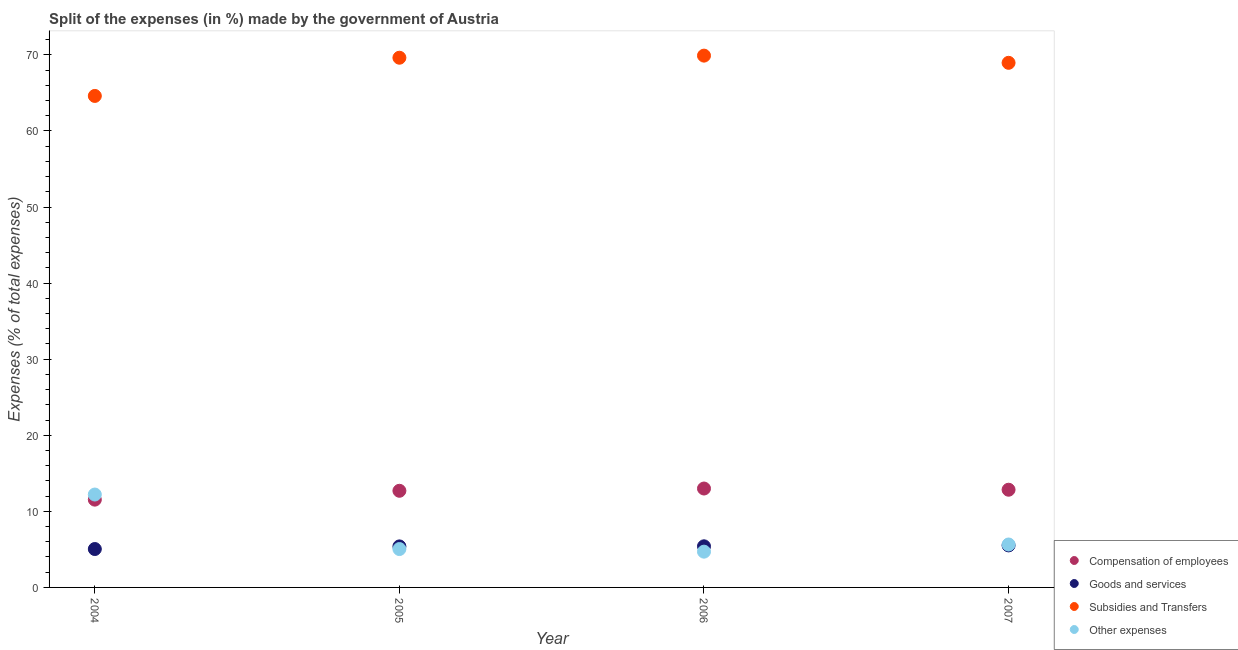How many different coloured dotlines are there?
Your response must be concise. 4. Is the number of dotlines equal to the number of legend labels?
Give a very brief answer. Yes. What is the percentage of amount spent on goods and services in 2004?
Your answer should be very brief. 5.05. Across all years, what is the maximum percentage of amount spent on subsidies?
Offer a terse response. 69.9. Across all years, what is the minimum percentage of amount spent on compensation of employees?
Keep it short and to the point. 11.54. In which year was the percentage of amount spent on other expenses maximum?
Ensure brevity in your answer.  2004. What is the total percentage of amount spent on subsidies in the graph?
Your answer should be compact. 273.09. What is the difference between the percentage of amount spent on compensation of employees in 2005 and that in 2007?
Keep it short and to the point. -0.14. What is the difference between the percentage of amount spent on goods and services in 2006 and the percentage of amount spent on other expenses in 2005?
Offer a very short reply. 0.36. What is the average percentage of amount spent on compensation of employees per year?
Your answer should be compact. 12.52. In the year 2004, what is the difference between the percentage of amount spent on compensation of employees and percentage of amount spent on subsidies?
Keep it short and to the point. -53.07. In how many years, is the percentage of amount spent on subsidies greater than 26 %?
Keep it short and to the point. 4. What is the ratio of the percentage of amount spent on compensation of employees in 2004 to that in 2005?
Ensure brevity in your answer.  0.91. Is the difference between the percentage of amount spent on compensation of employees in 2005 and 2006 greater than the difference between the percentage of amount spent on subsidies in 2005 and 2006?
Offer a very short reply. No. What is the difference between the highest and the second highest percentage of amount spent on compensation of employees?
Ensure brevity in your answer.  0.16. What is the difference between the highest and the lowest percentage of amount spent on goods and services?
Provide a succinct answer. 0.48. In how many years, is the percentage of amount spent on compensation of employees greater than the average percentage of amount spent on compensation of employees taken over all years?
Make the answer very short. 3. Is it the case that in every year, the sum of the percentage of amount spent on compensation of employees and percentage of amount spent on goods and services is greater than the percentage of amount spent on subsidies?
Your response must be concise. No. Is the percentage of amount spent on subsidies strictly greater than the percentage of amount spent on compensation of employees over the years?
Your answer should be compact. Yes. Is the percentage of amount spent on goods and services strictly less than the percentage of amount spent on compensation of employees over the years?
Your answer should be very brief. Yes. Does the graph contain any zero values?
Keep it short and to the point. No. Does the graph contain grids?
Your response must be concise. No. What is the title of the graph?
Make the answer very short. Split of the expenses (in %) made by the government of Austria. What is the label or title of the X-axis?
Your response must be concise. Year. What is the label or title of the Y-axis?
Offer a very short reply. Expenses (% of total expenses). What is the Expenses (% of total expenses) of Compensation of employees in 2004?
Provide a short and direct response. 11.54. What is the Expenses (% of total expenses) of Goods and services in 2004?
Give a very brief answer. 5.05. What is the Expenses (% of total expenses) in Subsidies and Transfers in 2004?
Make the answer very short. 64.61. What is the Expenses (% of total expenses) in Other expenses in 2004?
Your answer should be very brief. 12.21. What is the Expenses (% of total expenses) of Compensation of employees in 2005?
Ensure brevity in your answer.  12.7. What is the Expenses (% of total expenses) in Goods and services in 2005?
Your answer should be very brief. 5.39. What is the Expenses (% of total expenses) in Subsidies and Transfers in 2005?
Make the answer very short. 69.63. What is the Expenses (% of total expenses) in Other expenses in 2005?
Provide a succinct answer. 5.04. What is the Expenses (% of total expenses) in Compensation of employees in 2006?
Keep it short and to the point. 13. What is the Expenses (% of total expenses) in Goods and services in 2006?
Provide a succinct answer. 5.4. What is the Expenses (% of total expenses) of Subsidies and Transfers in 2006?
Your response must be concise. 69.9. What is the Expenses (% of total expenses) of Other expenses in 2006?
Offer a terse response. 4.7. What is the Expenses (% of total expenses) in Compensation of employees in 2007?
Give a very brief answer. 12.84. What is the Expenses (% of total expenses) in Goods and services in 2007?
Provide a succinct answer. 5.52. What is the Expenses (% of total expenses) in Subsidies and Transfers in 2007?
Ensure brevity in your answer.  68.96. What is the Expenses (% of total expenses) of Other expenses in 2007?
Offer a terse response. 5.64. Across all years, what is the maximum Expenses (% of total expenses) of Compensation of employees?
Your answer should be compact. 13. Across all years, what is the maximum Expenses (% of total expenses) in Goods and services?
Give a very brief answer. 5.52. Across all years, what is the maximum Expenses (% of total expenses) in Subsidies and Transfers?
Your answer should be very brief. 69.9. Across all years, what is the maximum Expenses (% of total expenses) of Other expenses?
Provide a succinct answer. 12.21. Across all years, what is the minimum Expenses (% of total expenses) in Compensation of employees?
Give a very brief answer. 11.54. Across all years, what is the minimum Expenses (% of total expenses) in Goods and services?
Provide a succinct answer. 5.05. Across all years, what is the minimum Expenses (% of total expenses) in Subsidies and Transfers?
Offer a terse response. 64.61. Across all years, what is the minimum Expenses (% of total expenses) in Other expenses?
Provide a succinct answer. 4.7. What is the total Expenses (% of total expenses) of Compensation of employees in the graph?
Keep it short and to the point. 50.08. What is the total Expenses (% of total expenses) of Goods and services in the graph?
Ensure brevity in your answer.  21.37. What is the total Expenses (% of total expenses) of Subsidies and Transfers in the graph?
Your response must be concise. 273.09. What is the total Expenses (% of total expenses) of Other expenses in the graph?
Offer a terse response. 27.6. What is the difference between the Expenses (% of total expenses) of Compensation of employees in 2004 and that in 2005?
Ensure brevity in your answer.  -1.16. What is the difference between the Expenses (% of total expenses) in Goods and services in 2004 and that in 2005?
Your answer should be very brief. -0.34. What is the difference between the Expenses (% of total expenses) of Subsidies and Transfers in 2004 and that in 2005?
Ensure brevity in your answer.  -5.02. What is the difference between the Expenses (% of total expenses) of Other expenses in 2004 and that in 2005?
Make the answer very short. 7.17. What is the difference between the Expenses (% of total expenses) of Compensation of employees in 2004 and that in 2006?
Keep it short and to the point. -1.46. What is the difference between the Expenses (% of total expenses) in Goods and services in 2004 and that in 2006?
Your response must be concise. -0.36. What is the difference between the Expenses (% of total expenses) of Subsidies and Transfers in 2004 and that in 2006?
Give a very brief answer. -5.3. What is the difference between the Expenses (% of total expenses) of Other expenses in 2004 and that in 2006?
Your answer should be compact. 7.51. What is the difference between the Expenses (% of total expenses) in Compensation of employees in 2004 and that in 2007?
Give a very brief answer. -1.3. What is the difference between the Expenses (% of total expenses) in Goods and services in 2004 and that in 2007?
Your response must be concise. -0.48. What is the difference between the Expenses (% of total expenses) in Subsidies and Transfers in 2004 and that in 2007?
Offer a terse response. -4.35. What is the difference between the Expenses (% of total expenses) in Other expenses in 2004 and that in 2007?
Ensure brevity in your answer.  6.57. What is the difference between the Expenses (% of total expenses) of Compensation of employees in 2005 and that in 2006?
Provide a short and direct response. -0.3. What is the difference between the Expenses (% of total expenses) in Goods and services in 2005 and that in 2006?
Your response must be concise. -0.01. What is the difference between the Expenses (% of total expenses) of Subsidies and Transfers in 2005 and that in 2006?
Your answer should be very brief. -0.28. What is the difference between the Expenses (% of total expenses) of Other expenses in 2005 and that in 2006?
Ensure brevity in your answer.  0.34. What is the difference between the Expenses (% of total expenses) of Compensation of employees in 2005 and that in 2007?
Your response must be concise. -0.14. What is the difference between the Expenses (% of total expenses) of Goods and services in 2005 and that in 2007?
Your answer should be compact. -0.13. What is the difference between the Expenses (% of total expenses) of Subsidies and Transfers in 2005 and that in 2007?
Ensure brevity in your answer.  0.67. What is the difference between the Expenses (% of total expenses) in Other expenses in 2005 and that in 2007?
Provide a short and direct response. -0.6. What is the difference between the Expenses (% of total expenses) of Compensation of employees in 2006 and that in 2007?
Provide a succinct answer. 0.16. What is the difference between the Expenses (% of total expenses) in Goods and services in 2006 and that in 2007?
Make the answer very short. -0.12. What is the difference between the Expenses (% of total expenses) of Subsidies and Transfers in 2006 and that in 2007?
Make the answer very short. 0.95. What is the difference between the Expenses (% of total expenses) of Other expenses in 2006 and that in 2007?
Provide a short and direct response. -0.94. What is the difference between the Expenses (% of total expenses) of Compensation of employees in 2004 and the Expenses (% of total expenses) of Goods and services in 2005?
Provide a short and direct response. 6.15. What is the difference between the Expenses (% of total expenses) in Compensation of employees in 2004 and the Expenses (% of total expenses) in Subsidies and Transfers in 2005?
Offer a terse response. -58.09. What is the difference between the Expenses (% of total expenses) of Compensation of employees in 2004 and the Expenses (% of total expenses) of Other expenses in 2005?
Ensure brevity in your answer.  6.49. What is the difference between the Expenses (% of total expenses) of Goods and services in 2004 and the Expenses (% of total expenses) of Subsidies and Transfers in 2005?
Provide a short and direct response. -64.58. What is the difference between the Expenses (% of total expenses) of Goods and services in 2004 and the Expenses (% of total expenses) of Other expenses in 2005?
Give a very brief answer. 0. What is the difference between the Expenses (% of total expenses) in Subsidies and Transfers in 2004 and the Expenses (% of total expenses) in Other expenses in 2005?
Offer a very short reply. 59.56. What is the difference between the Expenses (% of total expenses) of Compensation of employees in 2004 and the Expenses (% of total expenses) of Goods and services in 2006?
Offer a very short reply. 6.13. What is the difference between the Expenses (% of total expenses) of Compensation of employees in 2004 and the Expenses (% of total expenses) of Subsidies and Transfers in 2006?
Your response must be concise. -58.36. What is the difference between the Expenses (% of total expenses) in Compensation of employees in 2004 and the Expenses (% of total expenses) in Other expenses in 2006?
Give a very brief answer. 6.84. What is the difference between the Expenses (% of total expenses) of Goods and services in 2004 and the Expenses (% of total expenses) of Subsidies and Transfers in 2006?
Provide a short and direct response. -64.86. What is the difference between the Expenses (% of total expenses) in Goods and services in 2004 and the Expenses (% of total expenses) in Other expenses in 2006?
Give a very brief answer. 0.35. What is the difference between the Expenses (% of total expenses) of Subsidies and Transfers in 2004 and the Expenses (% of total expenses) of Other expenses in 2006?
Ensure brevity in your answer.  59.9. What is the difference between the Expenses (% of total expenses) in Compensation of employees in 2004 and the Expenses (% of total expenses) in Goods and services in 2007?
Provide a succinct answer. 6.02. What is the difference between the Expenses (% of total expenses) in Compensation of employees in 2004 and the Expenses (% of total expenses) in Subsidies and Transfers in 2007?
Your response must be concise. -57.42. What is the difference between the Expenses (% of total expenses) of Compensation of employees in 2004 and the Expenses (% of total expenses) of Other expenses in 2007?
Ensure brevity in your answer.  5.89. What is the difference between the Expenses (% of total expenses) in Goods and services in 2004 and the Expenses (% of total expenses) in Subsidies and Transfers in 2007?
Provide a short and direct response. -63.91. What is the difference between the Expenses (% of total expenses) in Goods and services in 2004 and the Expenses (% of total expenses) in Other expenses in 2007?
Offer a very short reply. -0.6. What is the difference between the Expenses (% of total expenses) in Subsidies and Transfers in 2004 and the Expenses (% of total expenses) in Other expenses in 2007?
Your answer should be very brief. 58.96. What is the difference between the Expenses (% of total expenses) of Compensation of employees in 2005 and the Expenses (% of total expenses) of Goods and services in 2006?
Provide a short and direct response. 7.3. What is the difference between the Expenses (% of total expenses) in Compensation of employees in 2005 and the Expenses (% of total expenses) in Subsidies and Transfers in 2006?
Offer a terse response. -57.2. What is the difference between the Expenses (% of total expenses) of Compensation of employees in 2005 and the Expenses (% of total expenses) of Other expenses in 2006?
Provide a short and direct response. 8. What is the difference between the Expenses (% of total expenses) of Goods and services in 2005 and the Expenses (% of total expenses) of Subsidies and Transfers in 2006?
Provide a short and direct response. -64.51. What is the difference between the Expenses (% of total expenses) of Goods and services in 2005 and the Expenses (% of total expenses) of Other expenses in 2006?
Offer a very short reply. 0.69. What is the difference between the Expenses (% of total expenses) of Subsidies and Transfers in 2005 and the Expenses (% of total expenses) of Other expenses in 2006?
Your response must be concise. 64.93. What is the difference between the Expenses (% of total expenses) in Compensation of employees in 2005 and the Expenses (% of total expenses) in Goods and services in 2007?
Offer a very short reply. 7.18. What is the difference between the Expenses (% of total expenses) in Compensation of employees in 2005 and the Expenses (% of total expenses) in Subsidies and Transfers in 2007?
Keep it short and to the point. -56.26. What is the difference between the Expenses (% of total expenses) of Compensation of employees in 2005 and the Expenses (% of total expenses) of Other expenses in 2007?
Offer a terse response. 7.06. What is the difference between the Expenses (% of total expenses) in Goods and services in 2005 and the Expenses (% of total expenses) in Subsidies and Transfers in 2007?
Offer a terse response. -63.57. What is the difference between the Expenses (% of total expenses) of Goods and services in 2005 and the Expenses (% of total expenses) of Other expenses in 2007?
Give a very brief answer. -0.25. What is the difference between the Expenses (% of total expenses) in Subsidies and Transfers in 2005 and the Expenses (% of total expenses) in Other expenses in 2007?
Make the answer very short. 63.98. What is the difference between the Expenses (% of total expenses) of Compensation of employees in 2006 and the Expenses (% of total expenses) of Goods and services in 2007?
Make the answer very short. 7.48. What is the difference between the Expenses (% of total expenses) in Compensation of employees in 2006 and the Expenses (% of total expenses) in Subsidies and Transfers in 2007?
Provide a succinct answer. -55.96. What is the difference between the Expenses (% of total expenses) in Compensation of employees in 2006 and the Expenses (% of total expenses) in Other expenses in 2007?
Provide a short and direct response. 7.36. What is the difference between the Expenses (% of total expenses) in Goods and services in 2006 and the Expenses (% of total expenses) in Subsidies and Transfers in 2007?
Your response must be concise. -63.55. What is the difference between the Expenses (% of total expenses) of Goods and services in 2006 and the Expenses (% of total expenses) of Other expenses in 2007?
Provide a short and direct response. -0.24. What is the difference between the Expenses (% of total expenses) in Subsidies and Transfers in 2006 and the Expenses (% of total expenses) in Other expenses in 2007?
Your response must be concise. 64.26. What is the average Expenses (% of total expenses) of Compensation of employees per year?
Ensure brevity in your answer.  12.52. What is the average Expenses (% of total expenses) of Goods and services per year?
Provide a short and direct response. 5.34. What is the average Expenses (% of total expenses) in Subsidies and Transfers per year?
Keep it short and to the point. 68.27. What is the average Expenses (% of total expenses) in Other expenses per year?
Keep it short and to the point. 6.9. In the year 2004, what is the difference between the Expenses (% of total expenses) of Compensation of employees and Expenses (% of total expenses) of Goods and services?
Ensure brevity in your answer.  6.49. In the year 2004, what is the difference between the Expenses (% of total expenses) of Compensation of employees and Expenses (% of total expenses) of Subsidies and Transfers?
Give a very brief answer. -53.07. In the year 2004, what is the difference between the Expenses (% of total expenses) of Compensation of employees and Expenses (% of total expenses) of Other expenses?
Your response must be concise. -0.67. In the year 2004, what is the difference between the Expenses (% of total expenses) of Goods and services and Expenses (% of total expenses) of Subsidies and Transfers?
Offer a terse response. -59.56. In the year 2004, what is the difference between the Expenses (% of total expenses) of Goods and services and Expenses (% of total expenses) of Other expenses?
Provide a short and direct response. -7.16. In the year 2004, what is the difference between the Expenses (% of total expenses) of Subsidies and Transfers and Expenses (% of total expenses) of Other expenses?
Offer a terse response. 52.39. In the year 2005, what is the difference between the Expenses (% of total expenses) of Compensation of employees and Expenses (% of total expenses) of Goods and services?
Provide a succinct answer. 7.31. In the year 2005, what is the difference between the Expenses (% of total expenses) in Compensation of employees and Expenses (% of total expenses) in Subsidies and Transfers?
Offer a very short reply. -56.92. In the year 2005, what is the difference between the Expenses (% of total expenses) in Compensation of employees and Expenses (% of total expenses) in Other expenses?
Your response must be concise. 7.66. In the year 2005, what is the difference between the Expenses (% of total expenses) of Goods and services and Expenses (% of total expenses) of Subsidies and Transfers?
Your response must be concise. -64.23. In the year 2005, what is the difference between the Expenses (% of total expenses) in Goods and services and Expenses (% of total expenses) in Other expenses?
Provide a short and direct response. 0.35. In the year 2005, what is the difference between the Expenses (% of total expenses) of Subsidies and Transfers and Expenses (% of total expenses) of Other expenses?
Your response must be concise. 64.58. In the year 2006, what is the difference between the Expenses (% of total expenses) in Compensation of employees and Expenses (% of total expenses) in Goods and services?
Your answer should be very brief. 7.6. In the year 2006, what is the difference between the Expenses (% of total expenses) in Compensation of employees and Expenses (% of total expenses) in Subsidies and Transfers?
Make the answer very short. -56.9. In the year 2006, what is the difference between the Expenses (% of total expenses) of Compensation of employees and Expenses (% of total expenses) of Other expenses?
Your response must be concise. 8.3. In the year 2006, what is the difference between the Expenses (% of total expenses) in Goods and services and Expenses (% of total expenses) in Subsidies and Transfers?
Keep it short and to the point. -64.5. In the year 2006, what is the difference between the Expenses (% of total expenses) in Goods and services and Expenses (% of total expenses) in Other expenses?
Provide a short and direct response. 0.7. In the year 2006, what is the difference between the Expenses (% of total expenses) of Subsidies and Transfers and Expenses (% of total expenses) of Other expenses?
Offer a very short reply. 65.2. In the year 2007, what is the difference between the Expenses (% of total expenses) of Compensation of employees and Expenses (% of total expenses) of Goods and services?
Your response must be concise. 7.32. In the year 2007, what is the difference between the Expenses (% of total expenses) of Compensation of employees and Expenses (% of total expenses) of Subsidies and Transfers?
Offer a very short reply. -56.12. In the year 2007, what is the difference between the Expenses (% of total expenses) of Compensation of employees and Expenses (% of total expenses) of Other expenses?
Your answer should be very brief. 7.2. In the year 2007, what is the difference between the Expenses (% of total expenses) in Goods and services and Expenses (% of total expenses) in Subsidies and Transfers?
Offer a very short reply. -63.43. In the year 2007, what is the difference between the Expenses (% of total expenses) in Goods and services and Expenses (% of total expenses) in Other expenses?
Give a very brief answer. -0.12. In the year 2007, what is the difference between the Expenses (% of total expenses) in Subsidies and Transfers and Expenses (% of total expenses) in Other expenses?
Your answer should be very brief. 63.31. What is the ratio of the Expenses (% of total expenses) in Compensation of employees in 2004 to that in 2005?
Your response must be concise. 0.91. What is the ratio of the Expenses (% of total expenses) in Goods and services in 2004 to that in 2005?
Offer a terse response. 0.94. What is the ratio of the Expenses (% of total expenses) in Subsidies and Transfers in 2004 to that in 2005?
Your answer should be compact. 0.93. What is the ratio of the Expenses (% of total expenses) of Other expenses in 2004 to that in 2005?
Offer a very short reply. 2.42. What is the ratio of the Expenses (% of total expenses) in Compensation of employees in 2004 to that in 2006?
Make the answer very short. 0.89. What is the ratio of the Expenses (% of total expenses) in Goods and services in 2004 to that in 2006?
Provide a short and direct response. 0.93. What is the ratio of the Expenses (% of total expenses) in Subsidies and Transfers in 2004 to that in 2006?
Keep it short and to the point. 0.92. What is the ratio of the Expenses (% of total expenses) of Other expenses in 2004 to that in 2006?
Your answer should be compact. 2.6. What is the ratio of the Expenses (% of total expenses) of Compensation of employees in 2004 to that in 2007?
Give a very brief answer. 0.9. What is the ratio of the Expenses (% of total expenses) of Goods and services in 2004 to that in 2007?
Make the answer very short. 0.91. What is the ratio of the Expenses (% of total expenses) of Subsidies and Transfers in 2004 to that in 2007?
Offer a very short reply. 0.94. What is the ratio of the Expenses (% of total expenses) of Other expenses in 2004 to that in 2007?
Your answer should be compact. 2.16. What is the ratio of the Expenses (% of total expenses) of Compensation of employees in 2005 to that in 2006?
Your answer should be compact. 0.98. What is the ratio of the Expenses (% of total expenses) of Goods and services in 2005 to that in 2006?
Provide a succinct answer. 1. What is the ratio of the Expenses (% of total expenses) in Subsidies and Transfers in 2005 to that in 2006?
Give a very brief answer. 1. What is the ratio of the Expenses (% of total expenses) of Other expenses in 2005 to that in 2006?
Ensure brevity in your answer.  1.07. What is the ratio of the Expenses (% of total expenses) of Goods and services in 2005 to that in 2007?
Your response must be concise. 0.98. What is the ratio of the Expenses (% of total expenses) of Subsidies and Transfers in 2005 to that in 2007?
Give a very brief answer. 1.01. What is the ratio of the Expenses (% of total expenses) of Other expenses in 2005 to that in 2007?
Offer a very short reply. 0.89. What is the ratio of the Expenses (% of total expenses) in Compensation of employees in 2006 to that in 2007?
Offer a very short reply. 1.01. What is the ratio of the Expenses (% of total expenses) of Goods and services in 2006 to that in 2007?
Your answer should be compact. 0.98. What is the ratio of the Expenses (% of total expenses) in Subsidies and Transfers in 2006 to that in 2007?
Your answer should be compact. 1.01. What is the ratio of the Expenses (% of total expenses) of Other expenses in 2006 to that in 2007?
Your response must be concise. 0.83. What is the difference between the highest and the second highest Expenses (% of total expenses) in Compensation of employees?
Provide a succinct answer. 0.16. What is the difference between the highest and the second highest Expenses (% of total expenses) in Goods and services?
Provide a short and direct response. 0.12. What is the difference between the highest and the second highest Expenses (% of total expenses) of Subsidies and Transfers?
Ensure brevity in your answer.  0.28. What is the difference between the highest and the second highest Expenses (% of total expenses) in Other expenses?
Your response must be concise. 6.57. What is the difference between the highest and the lowest Expenses (% of total expenses) in Compensation of employees?
Offer a very short reply. 1.46. What is the difference between the highest and the lowest Expenses (% of total expenses) of Goods and services?
Make the answer very short. 0.48. What is the difference between the highest and the lowest Expenses (% of total expenses) in Subsidies and Transfers?
Offer a terse response. 5.3. What is the difference between the highest and the lowest Expenses (% of total expenses) of Other expenses?
Keep it short and to the point. 7.51. 